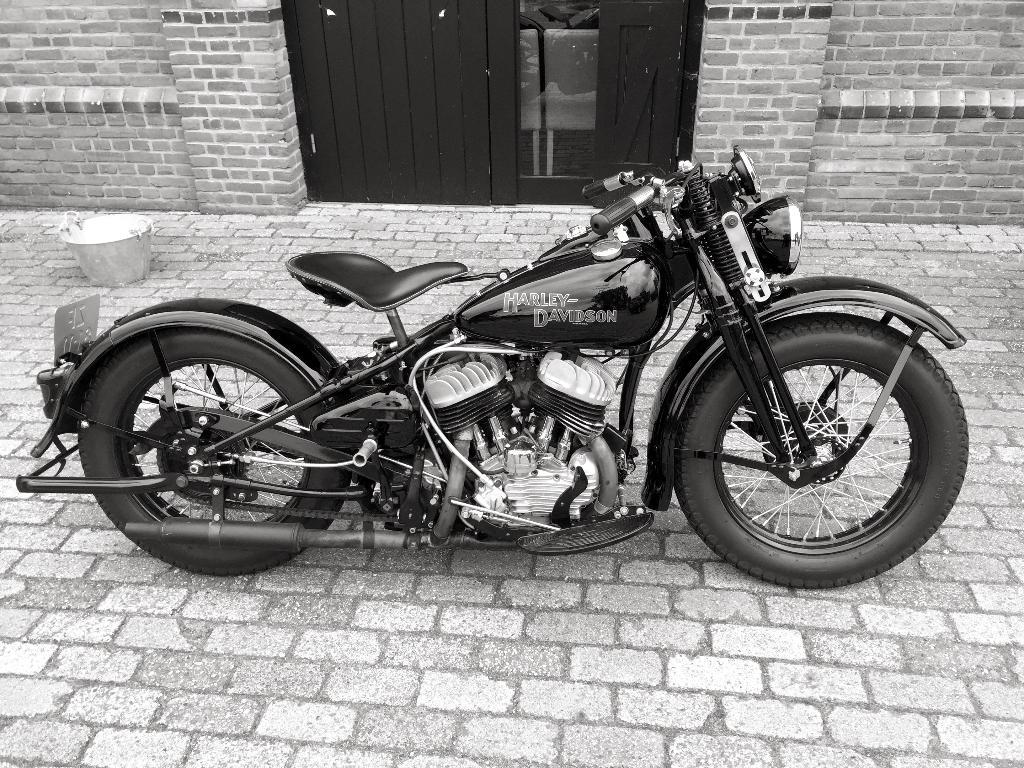What is the main subject of the image? The main subject of the image is a bike. Where is the bike located in the image? The bike is parked on the road. What is in the background of the image? There is a building in the background of the image. Can you describe any additional objects near the building? Yes, there is a bucket visible near the building. Can you tell me how many sons are visible in the image? There is no reference to any sons in the image; it features a bike parked on the road in front of a building. What type of person is walking alongside the bike in the image? There is no person walking alongside the bike in the image; it is parked and unattended. 